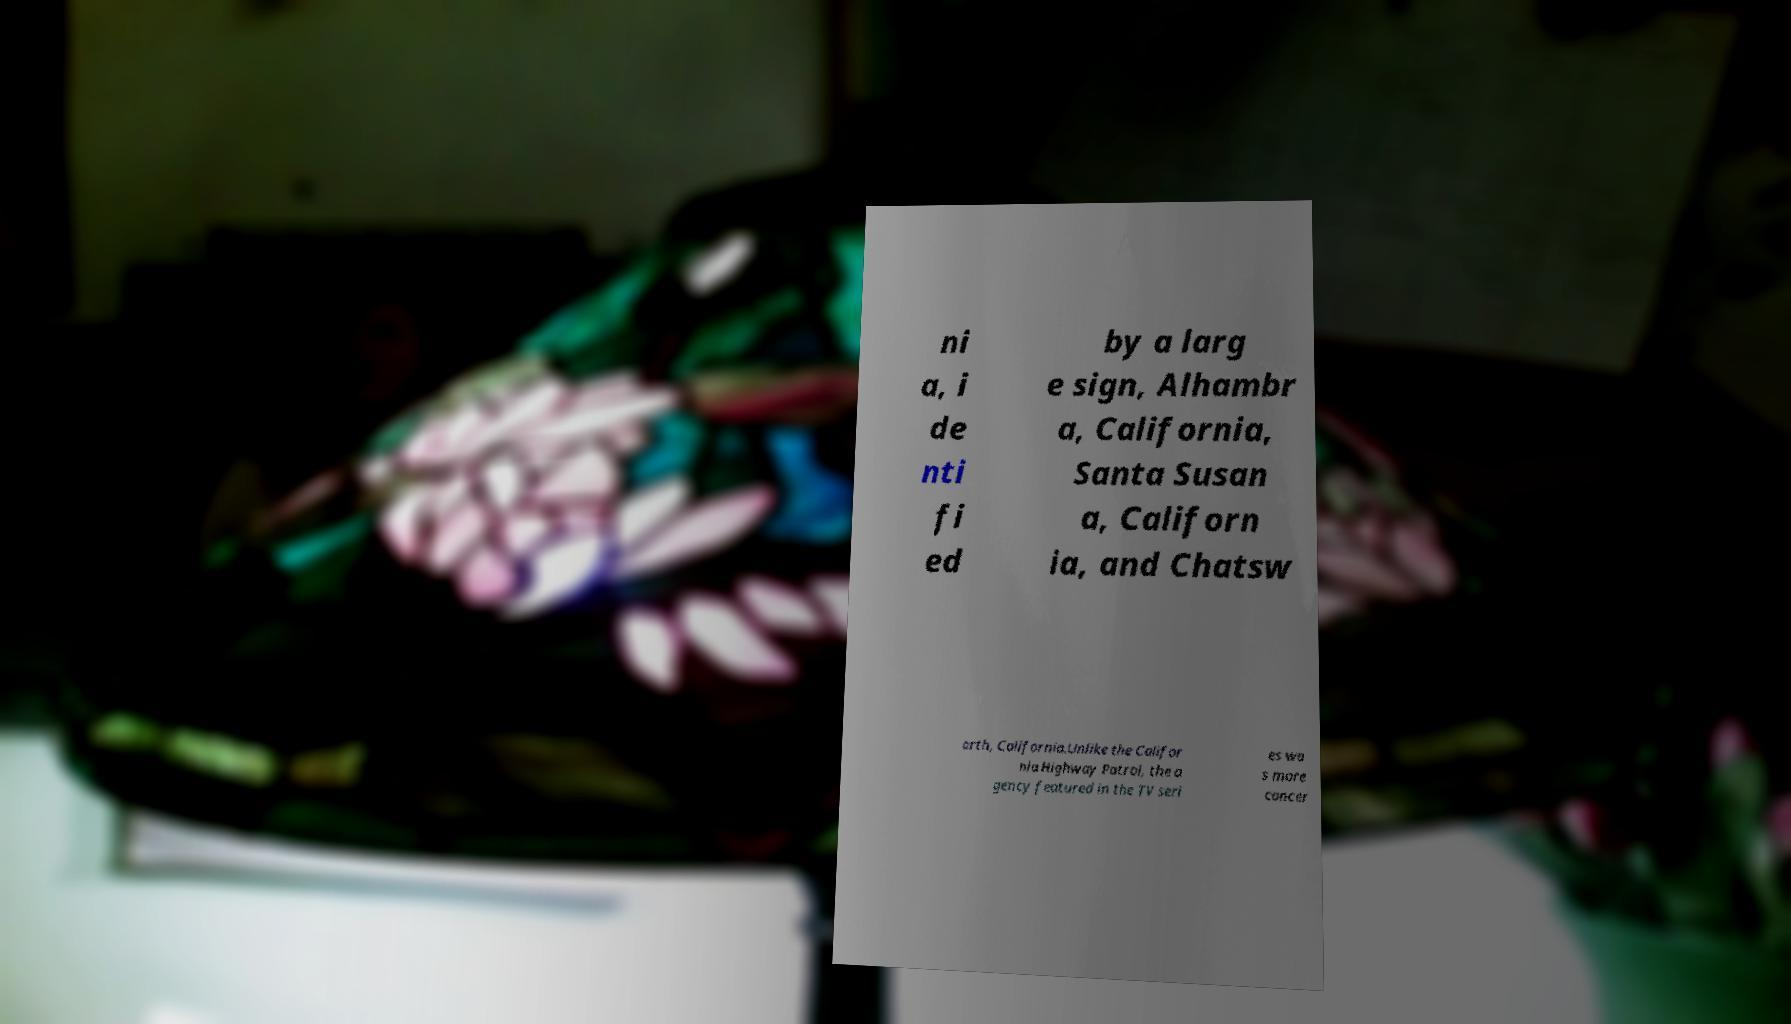What messages or text are displayed in this image? I need them in a readable, typed format. ni a, i de nti fi ed by a larg e sign, Alhambr a, California, Santa Susan a, Californ ia, and Chatsw orth, California.Unlike the Califor nia Highway Patrol, the a gency featured in the TV seri es wa s more concer 